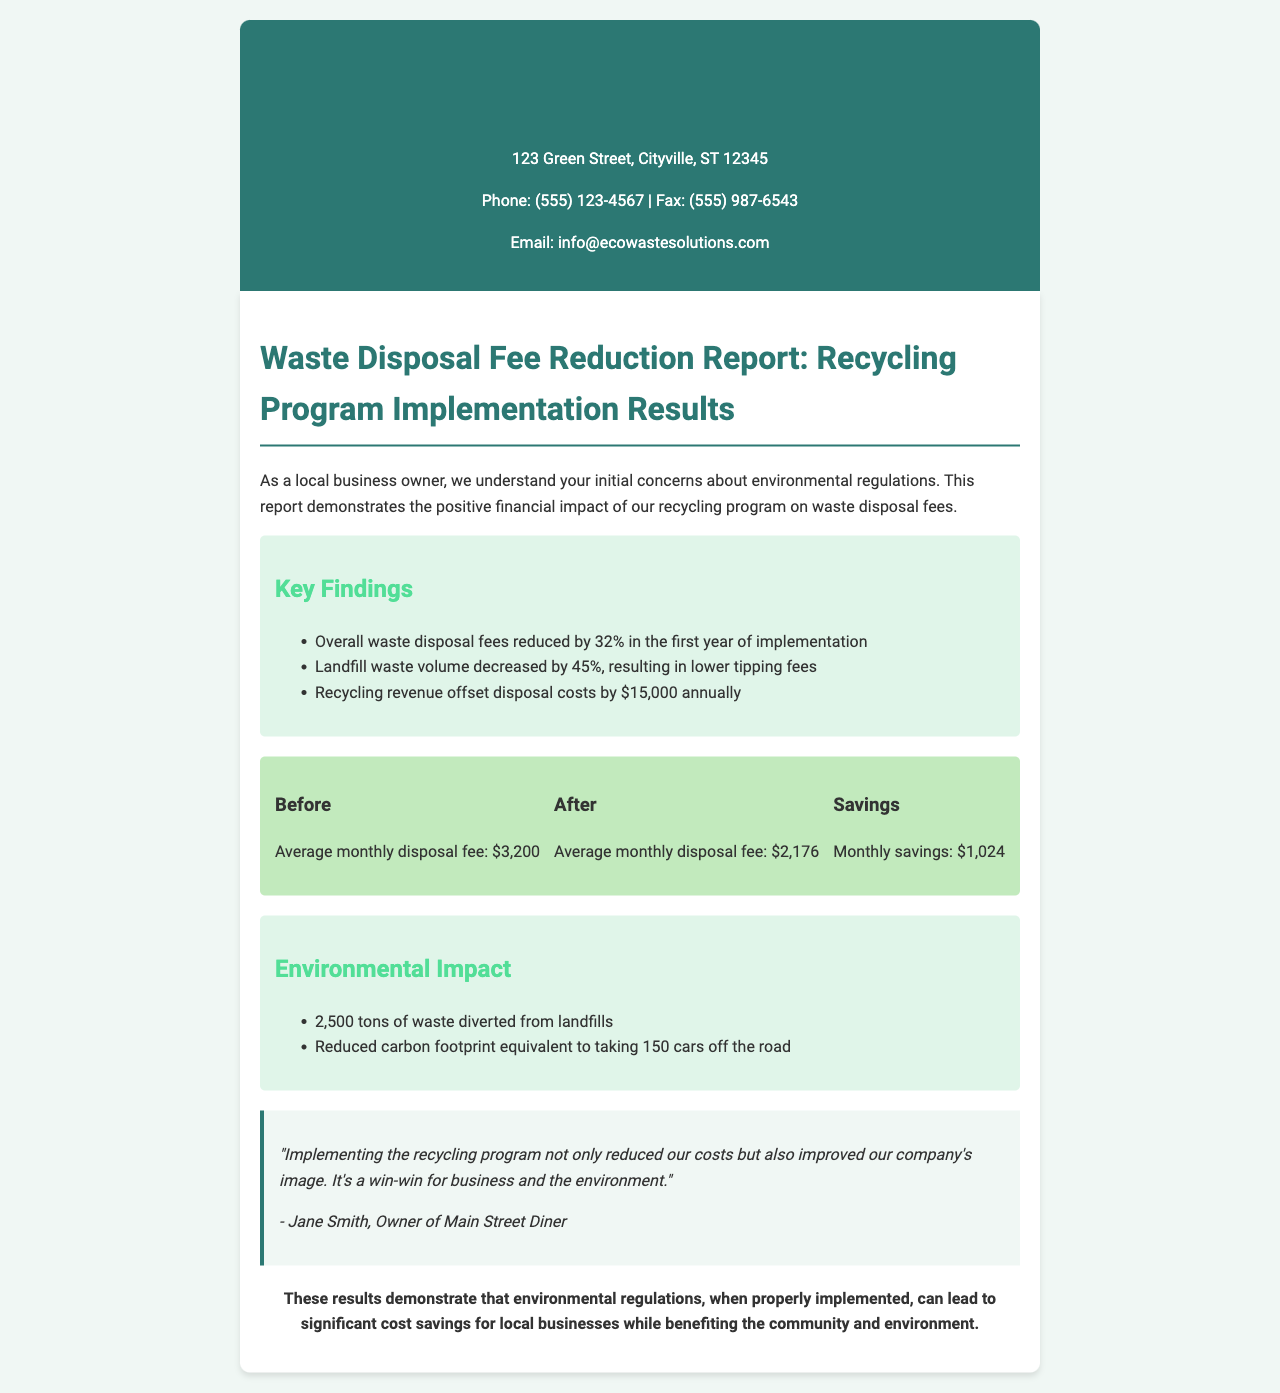What was the percentage reduction in overall waste disposal fees? The document states that overall waste disposal fees were reduced by 32% in the first year of implementation.
Answer: 32% What was the average monthly disposal fee before the recycling program? The document lists the average monthly disposal fee before the recycling program as $3,200.
Answer: $3,200 How much did the recycling revenue offset disposal costs annually? The report notes that recycling revenue offset disposal costs by $15,000 annually.
Answer: $15,000 What was the percentage decrease in landfill waste volume? According to the key findings, landfill waste volume decreased by 45%.
Answer: 45% How many tons of waste were diverted from landfills? The document mentions that 2,500 tons of waste were diverted from landfills.
Answer: 2,500 tons What is the equivalent reduction in carbon footprint mentioned in the report? The report states that the reduced carbon footprint is equivalent to taking 150 cars off the road.
Answer: 150 cars Who provided the testimonial in the report? The testimonial is from Jane Smith, the owner of Main Street Diner.
Answer: Jane Smith What is the background color of the header? The header background color is specified as #2c7873.
Answer: #2c7873 What is the estimated monthly savings after implementing the recycling program? The document indicates that the monthly savings after implementation is $1,024.
Answer: $1,024 